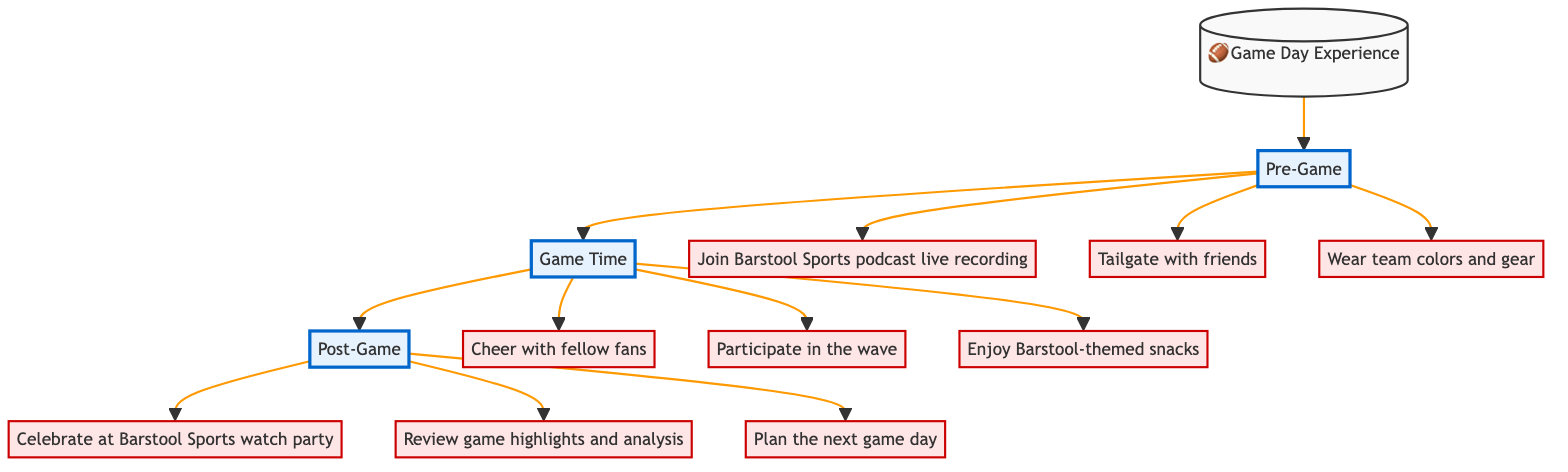What is the first phase of the game day experience? The flowchart shows the sequence of phases starting with "Pre-Game", which is connected directly to the "Start" node.
Answer: Pre-Game How many activities are listed under the game time phase? The diagram displays three activities branching off from the "Game Time" node: "Cheer with fellow fans", "Participate in the wave", and "Enjoy Barstool-themed snacks". Thus, the number of activities is counted as three.
Answer: 3 What activity is connected to the pre-game phase? There are three activities connected to the "Pre-Game" phase, specifically "Join Barstool Sports podcast live recording", "Tailgate with friends", and "Wear team colors and gear". One activity, for example, is "Join Barstool Sports podcast live recording".
Answer: Join Barstool Sports podcast live recording What does the post-game phase focus on? The activities listed under "Post-Game" include celebrating at a Barstool watch party, reviewing highlights, and planning the next game day, indicating a focus on post-game celebrations and analysis.
Answer: Celebrating at Barstool Sports watch party Which activity involves snacks? Among the activities under the "Game Time" phase, only "Enjoy Barstool-themed snacks" specifies snacks, differentiating it from other activities that involve cheering or participation.
Answer: Enjoy Barstool-themed snacks What is the last phase in the game day experience? The flowchart indicates that the last phase is "Post-Game", as it follows the "Game Time" phase and concludes the progression of the game day experience.
Answer: Post-Game How are the phases connected in the diagram? The phases are linked sequentially from "Start" to "Pre-Game", then "Game Time", and finally "Post-Game". Each phase transitions directly to the next, forming a linear flow.
Answer: Sequentially How many activities are included in the pre-game phase? The diagram lists three distinct activities associated with the "Pre-Game" phase: "Join Barstool Sports podcast live recording", "Tailgate with friends", and "Wear team colors and gear".
Answer: 3 